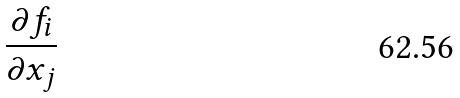Convert formula to latex. <formula><loc_0><loc_0><loc_500><loc_500>\frac { \partial f _ { i } } { \partial x _ { j } }</formula> 